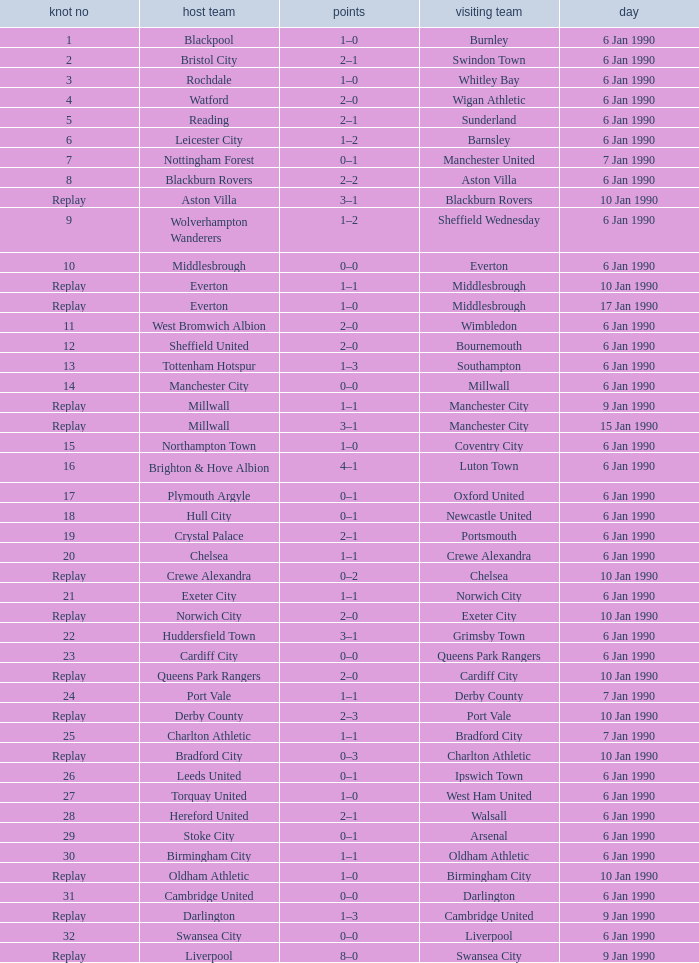What is the tie no of the game where exeter city was the home team? 21.0. Write the full table. {'header': ['knot no', 'host team', 'points', 'visiting team', 'day'], 'rows': [['1', 'Blackpool', '1–0', 'Burnley', '6 Jan 1990'], ['2', 'Bristol City', '2–1', 'Swindon Town', '6 Jan 1990'], ['3', 'Rochdale', '1–0', 'Whitley Bay', '6 Jan 1990'], ['4', 'Watford', '2–0', 'Wigan Athletic', '6 Jan 1990'], ['5', 'Reading', '2–1', 'Sunderland', '6 Jan 1990'], ['6', 'Leicester City', '1–2', 'Barnsley', '6 Jan 1990'], ['7', 'Nottingham Forest', '0–1', 'Manchester United', '7 Jan 1990'], ['8', 'Blackburn Rovers', '2–2', 'Aston Villa', '6 Jan 1990'], ['Replay', 'Aston Villa', '3–1', 'Blackburn Rovers', '10 Jan 1990'], ['9', 'Wolverhampton Wanderers', '1–2', 'Sheffield Wednesday', '6 Jan 1990'], ['10', 'Middlesbrough', '0–0', 'Everton', '6 Jan 1990'], ['Replay', 'Everton', '1–1', 'Middlesbrough', '10 Jan 1990'], ['Replay', 'Everton', '1–0', 'Middlesbrough', '17 Jan 1990'], ['11', 'West Bromwich Albion', '2–0', 'Wimbledon', '6 Jan 1990'], ['12', 'Sheffield United', '2–0', 'Bournemouth', '6 Jan 1990'], ['13', 'Tottenham Hotspur', '1–3', 'Southampton', '6 Jan 1990'], ['14', 'Manchester City', '0–0', 'Millwall', '6 Jan 1990'], ['Replay', 'Millwall', '1–1', 'Manchester City', '9 Jan 1990'], ['Replay', 'Millwall', '3–1', 'Manchester City', '15 Jan 1990'], ['15', 'Northampton Town', '1–0', 'Coventry City', '6 Jan 1990'], ['16', 'Brighton & Hove Albion', '4–1', 'Luton Town', '6 Jan 1990'], ['17', 'Plymouth Argyle', '0–1', 'Oxford United', '6 Jan 1990'], ['18', 'Hull City', '0–1', 'Newcastle United', '6 Jan 1990'], ['19', 'Crystal Palace', '2–1', 'Portsmouth', '6 Jan 1990'], ['20', 'Chelsea', '1–1', 'Crewe Alexandra', '6 Jan 1990'], ['Replay', 'Crewe Alexandra', '0–2', 'Chelsea', '10 Jan 1990'], ['21', 'Exeter City', '1–1', 'Norwich City', '6 Jan 1990'], ['Replay', 'Norwich City', '2–0', 'Exeter City', '10 Jan 1990'], ['22', 'Huddersfield Town', '3–1', 'Grimsby Town', '6 Jan 1990'], ['23', 'Cardiff City', '0–0', 'Queens Park Rangers', '6 Jan 1990'], ['Replay', 'Queens Park Rangers', '2–0', 'Cardiff City', '10 Jan 1990'], ['24', 'Port Vale', '1–1', 'Derby County', '7 Jan 1990'], ['Replay', 'Derby County', '2–3', 'Port Vale', '10 Jan 1990'], ['25', 'Charlton Athletic', '1–1', 'Bradford City', '7 Jan 1990'], ['Replay', 'Bradford City', '0–3', 'Charlton Athletic', '10 Jan 1990'], ['26', 'Leeds United', '0–1', 'Ipswich Town', '6 Jan 1990'], ['27', 'Torquay United', '1–0', 'West Ham United', '6 Jan 1990'], ['28', 'Hereford United', '2–1', 'Walsall', '6 Jan 1990'], ['29', 'Stoke City', '0–1', 'Arsenal', '6 Jan 1990'], ['30', 'Birmingham City', '1–1', 'Oldham Athletic', '6 Jan 1990'], ['Replay', 'Oldham Athletic', '1–0', 'Birmingham City', '10 Jan 1990'], ['31', 'Cambridge United', '0–0', 'Darlington', '6 Jan 1990'], ['Replay', 'Darlington', '1–3', 'Cambridge United', '9 Jan 1990'], ['32', 'Swansea City', '0–0', 'Liverpool', '6 Jan 1990'], ['Replay', 'Liverpool', '8–0', 'Swansea City', '9 Jan 1990']]} 